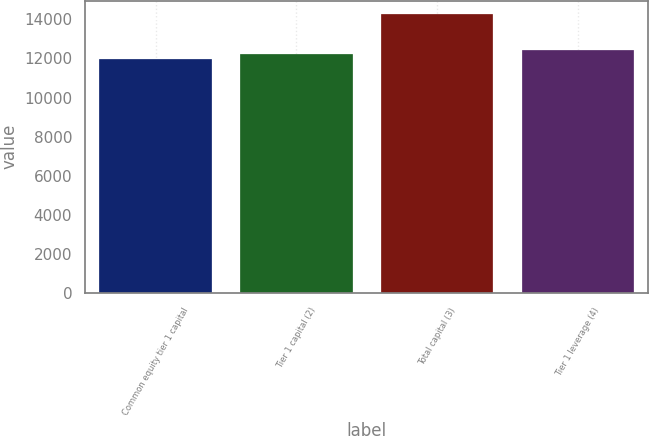Convert chart to OTSL. <chart><loc_0><loc_0><loc_500><loc_500><bar_chart><fcel>Common equity tier 1 capital<fcel>Tier 1 capital (2)<fcel>Total capital (3)<fcel>Tier 1 leverage (4)<nl><fcel>11994<fcel>12219.8<fcel>14252<fcel>12445.6<nl></chart> 